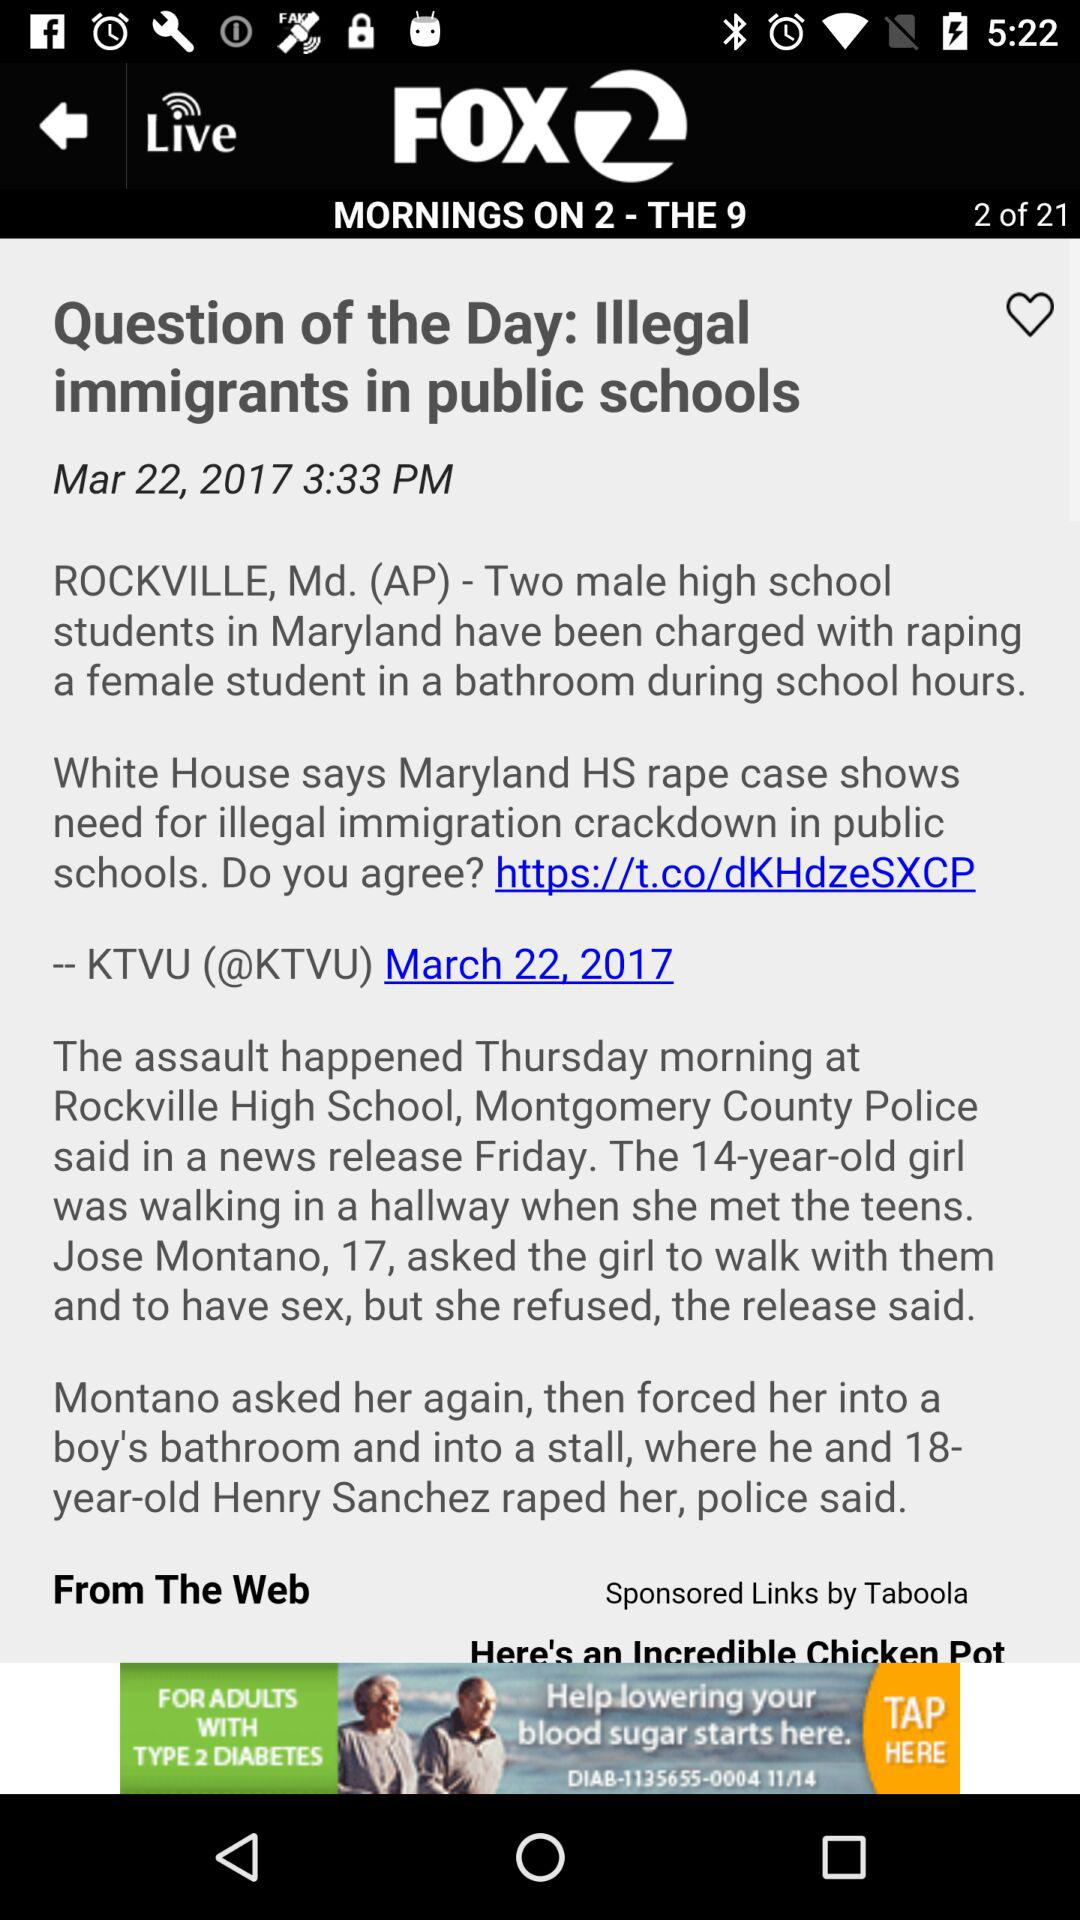How many years older is Henry Sanchez than Jose Montano?
Answer the question using a single word or phrase. 1 